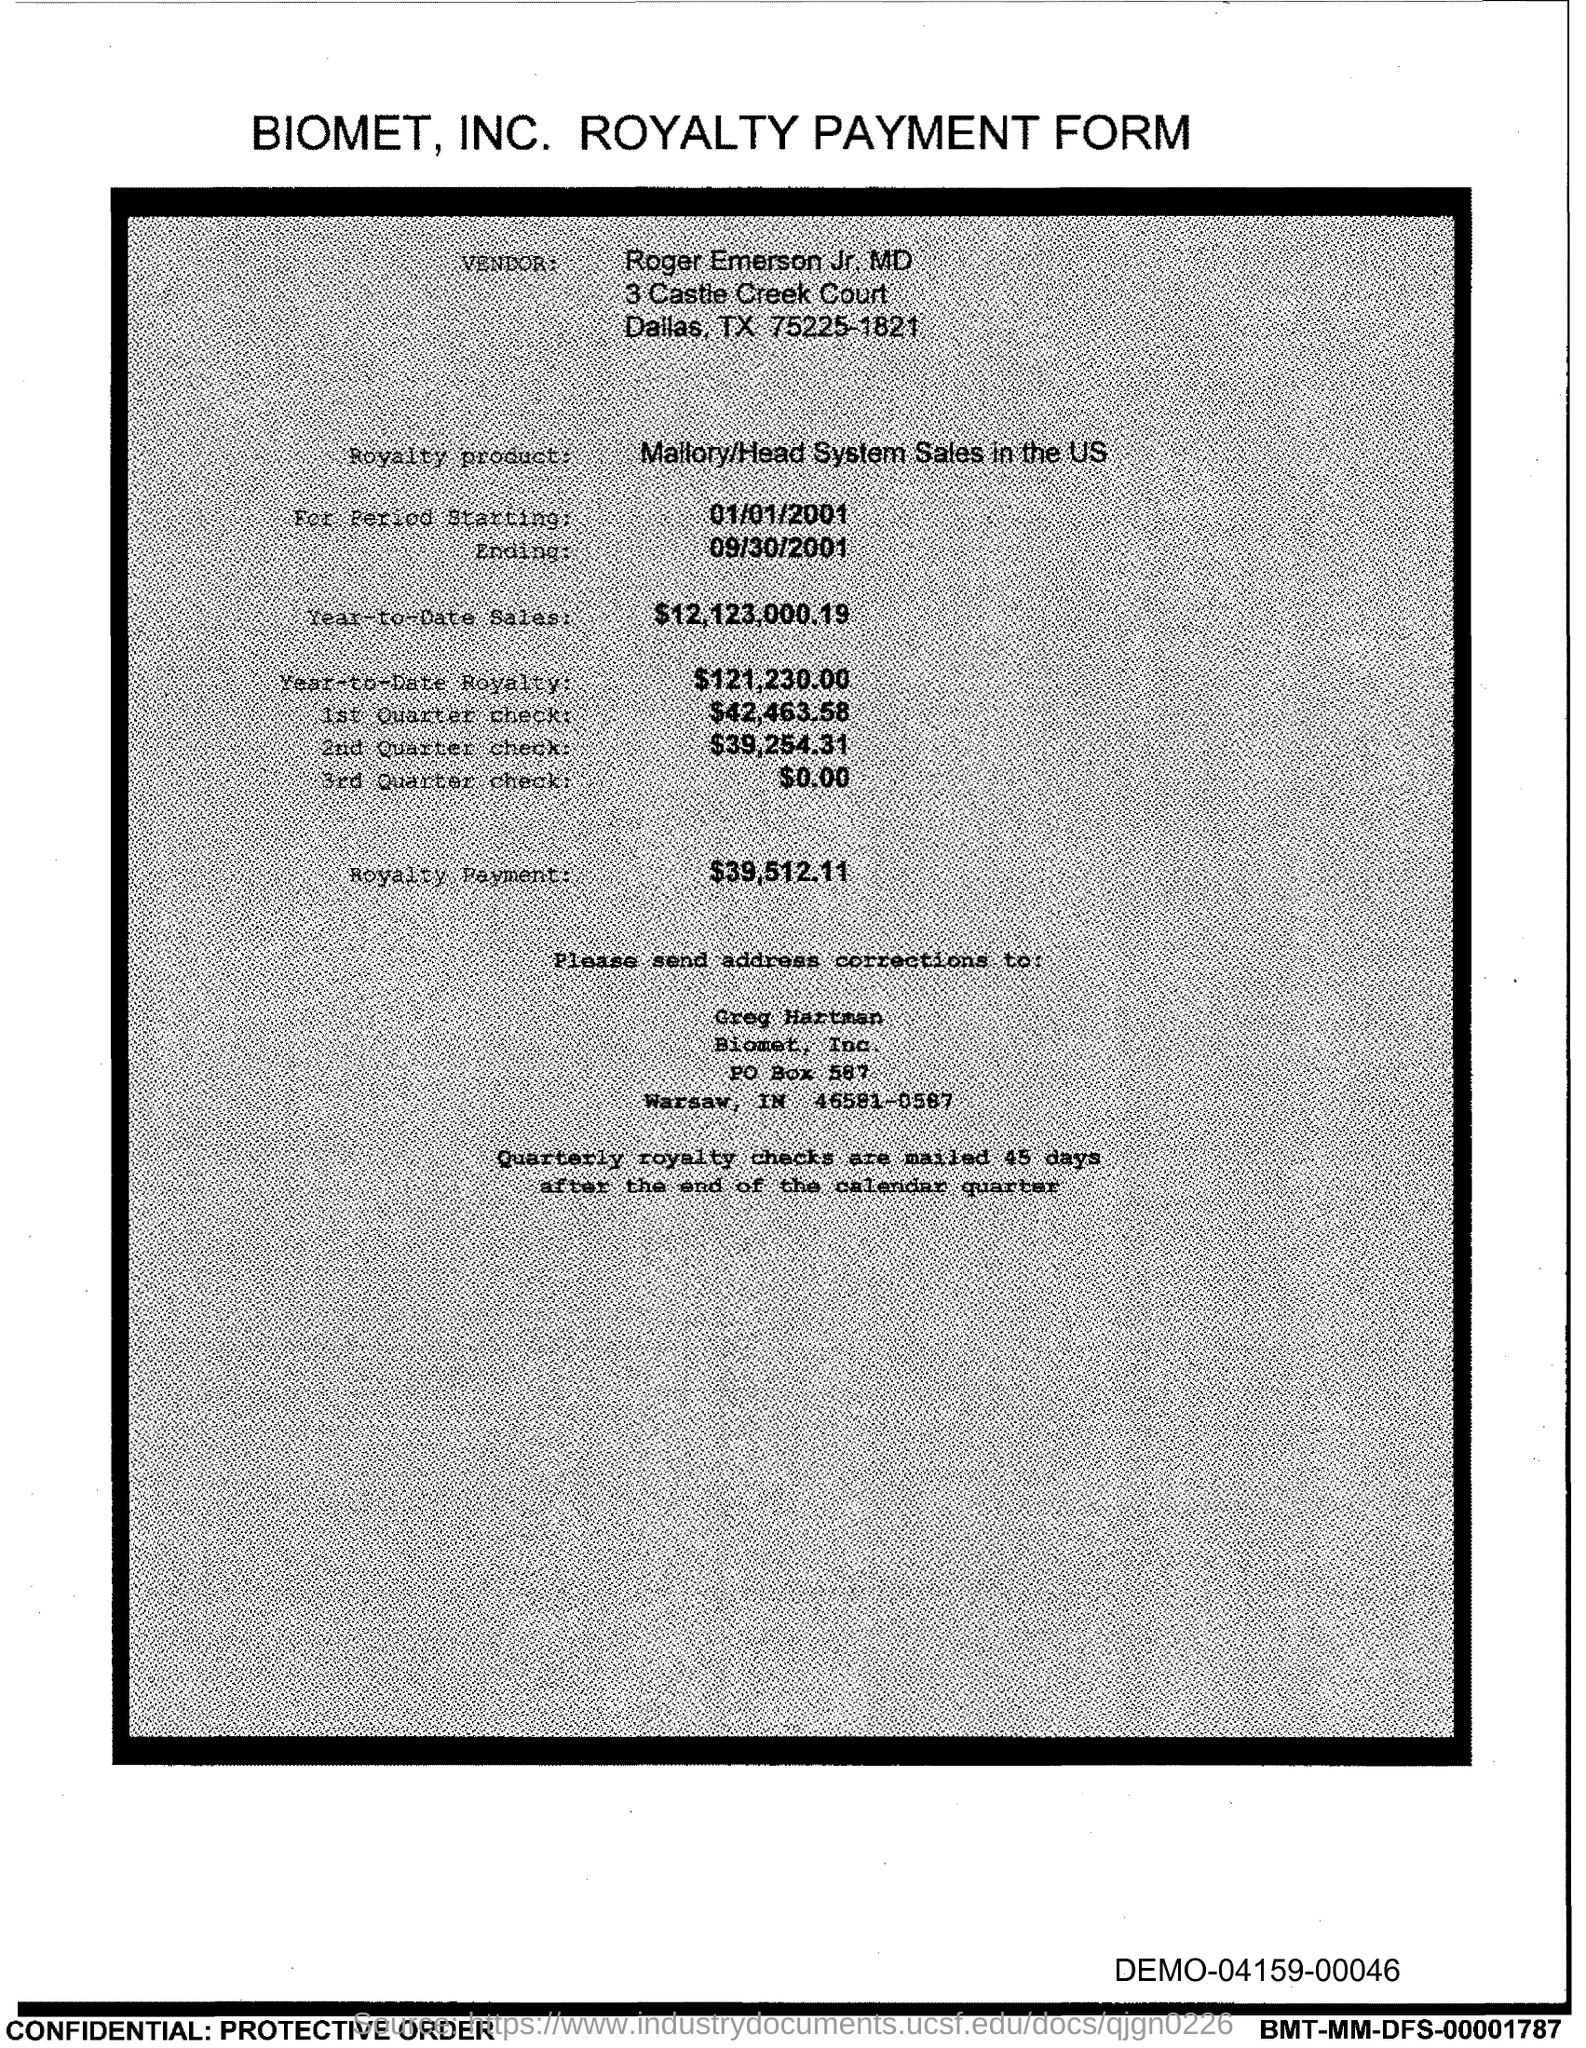What is the Year-to-Date-Sales?
Provide a short and direct response. $12,123,000.19. 